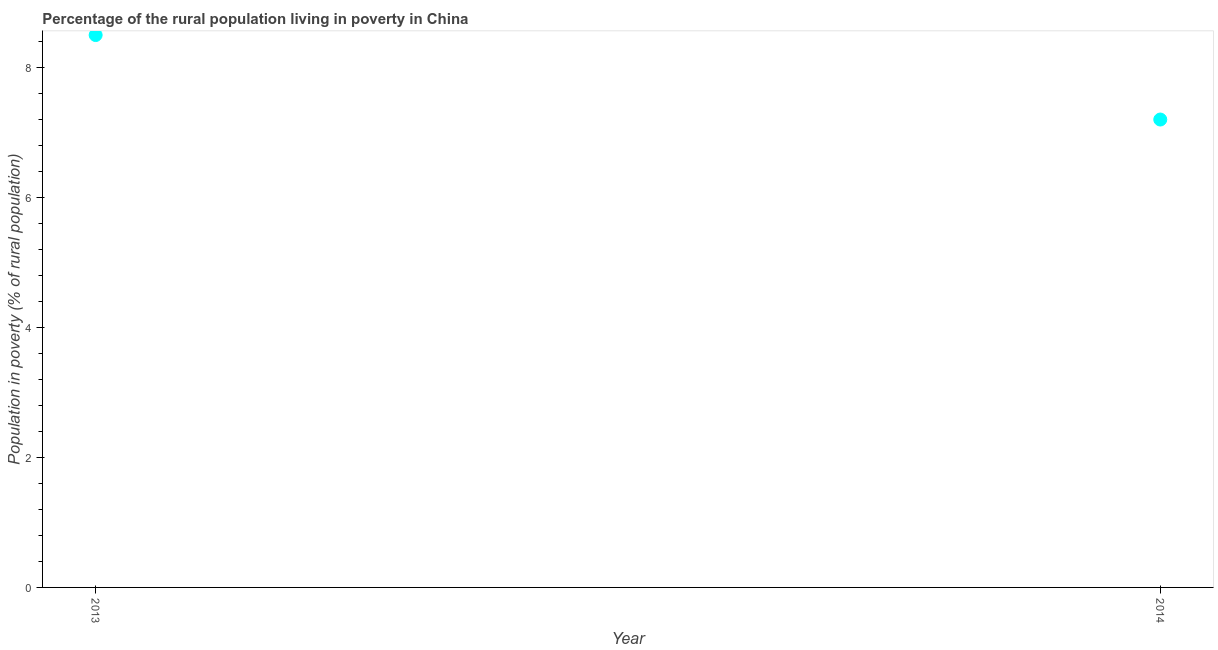Across all years, what is the minimum percentage of rural population living below poverty line?
Give a very brief answer. 7.2. In which year was the percentage of rural population living below poverty line maximum?
Provide a short and direct response. 2013. In which year was the percentage of rural population living below poverty line minimum?
Ensure brevity in your answer.  2014. What is the sum of the percentage of rural population living below poverty line?
Provide a succinct answer. 15.7. What is the difference between the percentage of rural population living below poverty line in 2013 and 2014?
Provide a short and direct response. 1.3. What is the average percentage of rural population living below poverty line per year?
Offer a very short reply. 7.85. What is the median percentage of rural population living below poverty line?
Give a very brief answer. 7.85. Do a majority of the years between 2013 and 2014 (inclusive) have percentage of rural population living below poverty line greater than 7.2 %?
Provide a short and direct response. No. What is the ratio of the percentage of rural population living below poverty line in 2013 to that in 2014?
Provide a succinct answer. 1.18. Is the percentage of rural population living below poverty line in 2013 less than that in 2014?
Provide a short and direct response. No. In how many years, is the percentage of rural population living below poverty line greater than the average percentage of rural population living below poverty line taken over all years?
Ensure brevity in your answer.  1. How many years are there in the graph?
Keep it short and to the point. 2. Are the values on the major ticks of Y-axis written in scientific E-notation?
Your response must be concise. No. Does the graph contain any zero values?
Give a very brief answer. No. What is the title of the graph?
Provide a succinct answer. Percentage of the rural population living in poverty in China. What is the label or title of the X-axis?
Offer a terse response. Year. What is the label or title of the Y-axis?
Provide a short and direct response. Population in poverty (% of rural population). What is the difference between the Population in poverty (% of rural population) in 2013 and 2014?
Your answer should be very brief. 1.3. What is the ratio of the Population in poverty (% of rural population) in 2013 to that in 2014?
Keep it short and to the point. 1.18. 